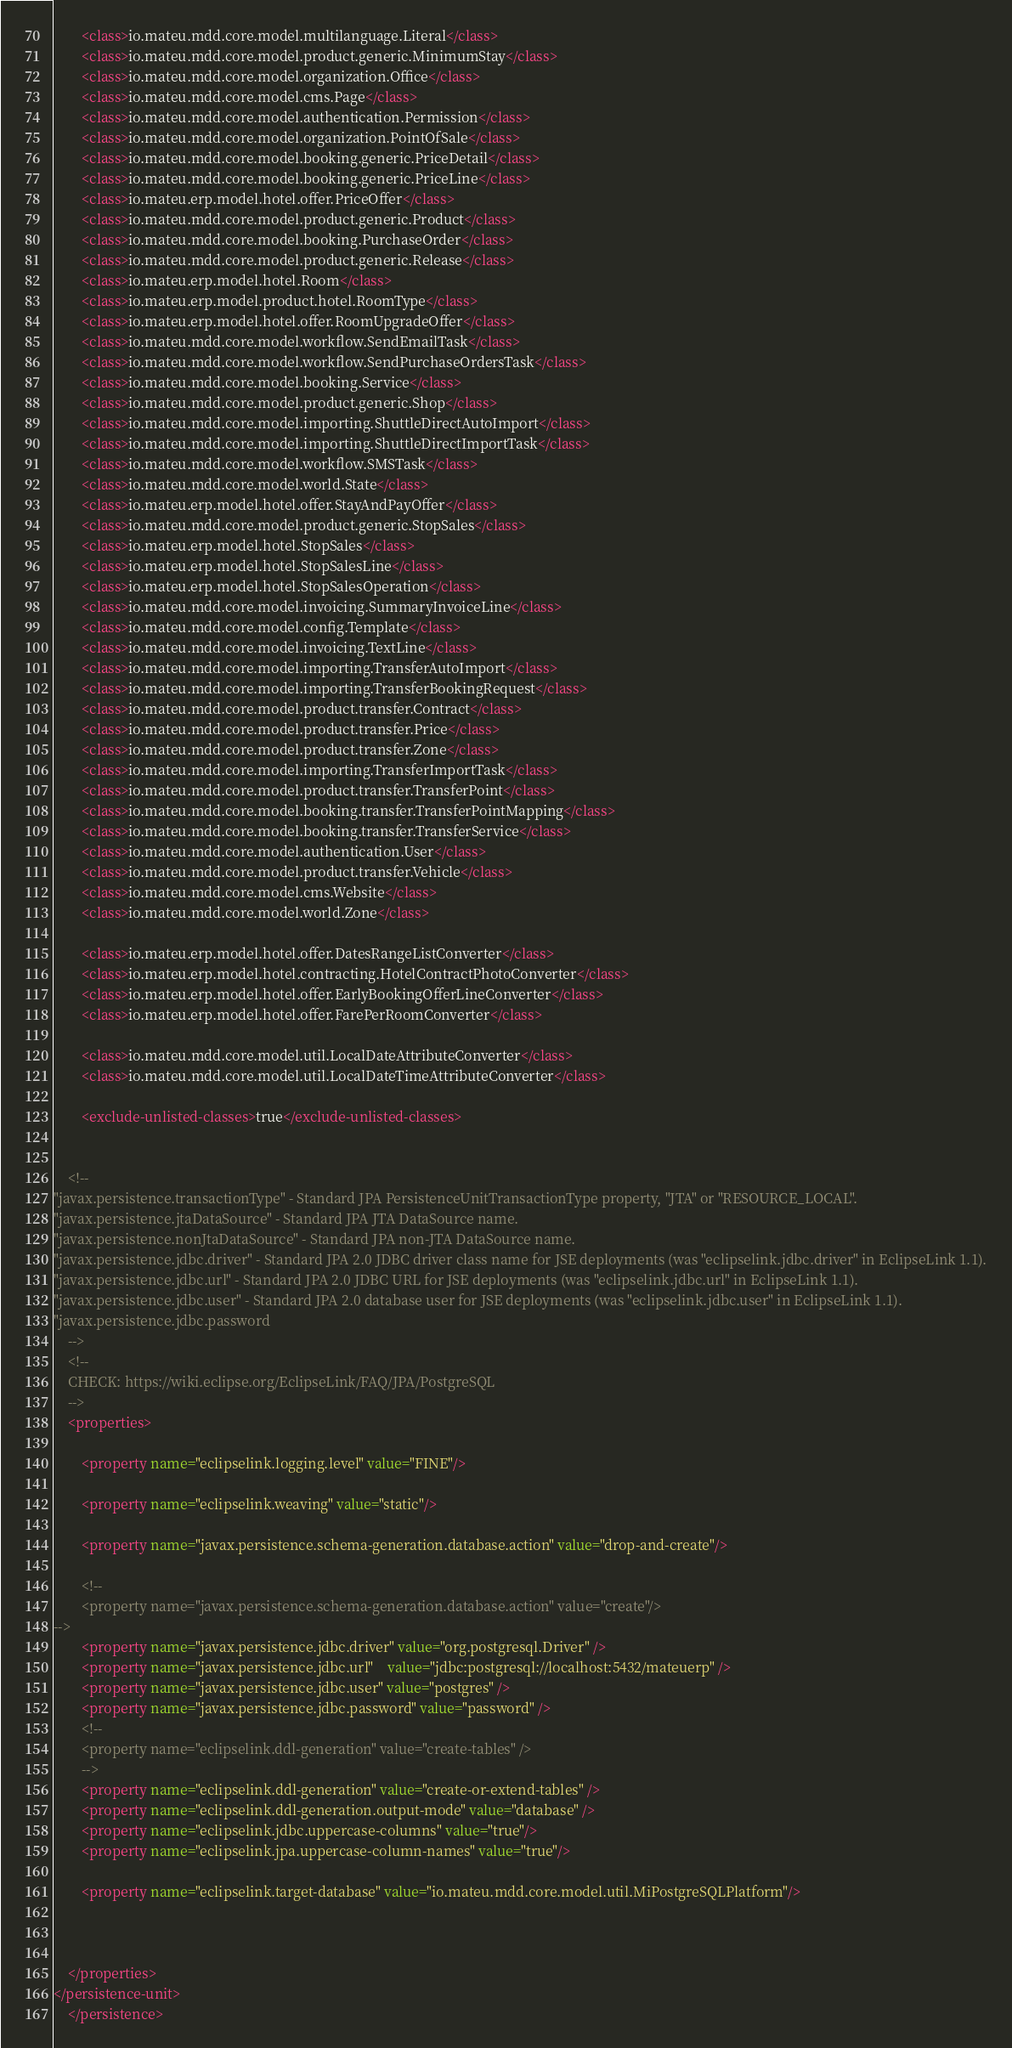<code> <loc_0><loc_0><loc_500><loc_500><_XML_>        <class>io.mateu.mdd.core.model.multilanguage.Literal</class>
        <class>io.mateu.mdd.core.model.product.generic.MinimumStay</class>
        <class>io.mateu.mdd.core.model.organization.Office</class>
        <class>io.mateu.mdd.core.model.cms.Page</class>
        <class>io.mateu.mdd.core.model.authentication.Permission</class>
        <class>io.mateu.mdd.core.model.organization.PointOfSale</class>
        <class>io.mateu.mdd.core.model.booking.generic.PriceDetail</class>
        <class>io.mateu.mdd.core.model.booking.generic.PriceLine</class>
        <class>io.mateu.erp.model.hotel.offer.PriceOffer</class>
        <class>io.mateu.mdd.core.model.product.generic.Product</class>
        <class>io.mateu.mdd.core.model.booking.PurchaseOrder</class>
        <class>io.mateu.mdd.core.model.product.generic.Release</class>
        <class>io.mateu.erp.model.hotel.Room</class>
        <class>io.mateu.erp.model.product.hotel.RoomType</class>
        <class>io.mateu.erp.model.hotel.offer.RoomUpgradeOffer</class>
        <class>io.mateu.mdd.core.model.workflow.SendEmailTask</class>
        <class>io.mateu.mdd.core.model.workflow.SendPurchaseOrdersTask</class>
        <class>io.mateu.mdd.core.model.booking.Service</class>
        <class>io.mateu.mdd.core.model.product.generic.Shop</class>
        <class>io.mateu.mdd.core.model.importing.ShuttleDirectAutoImport</class>
        <class>io.mateu.mdd.core.model.importing.ShuttleDirectImportTask</class>
        <class>io.mateu.mdd.core.model.workflow.SMSTask</class>
        <class>io.mateu.mdd.core.model.world.State</class>
        <class>io.mateu.erp.model.hotel.offer.StayAndPayOffer</class>
        <class>io.mateu.mdd.core.model.product.generic.StopSales</class>
        <class>io.mateu.erp.model.hotel.StopSales</class>
        <class>io.mateu.erp.model.hotel.StopSalesLine</class>
        <class>io.mateu.erp.model.hotel.StopSalesOperation</class>
        <class>io.mateu.mdd.core.model.invoicing.SummaryInvoiceLine</class>
        <class>io.mateu.mdd.core.model.config.Template</class>
        <class>io.mateu.mdd.core.model.invoicing.TextLine</class>
        <class>io.mateu.mdd.core.model.importing.TransferAutoImport</class>
        <class>io.mateu.mdd.core.model.importing.TransferBookingRequest</class>
        <class>io.mateu.mdd.core.model.product.transfer.Contract</class>
        <class>io.mateu.mdd.core.model.product.transfer.Price</class>
        <class>io.mateu.mdd.core.model.product.transfer.Zone</class>
        <class>io.mateu.mdd.core.model.importing.TransferImportTask</class>
        <class>io.mateu.mdd.core.model.product.transfer.TransferPoint</class>
        <class>io.mateu.mdd.core.model.booking.transfer.TransferPointMapping</class>
        <class>io.mateu.mdd.core.model.booking.transfer.TransferService</class>
        <class>io.mateu.mdd.core.model.authentication.User</class>
        <class>io.mateu.mdd.core.model.product.transfer.Vehicle</class>
        <class>io.mateu.mdd.core.model.cms.Website</class>
        <class>io.mateu.mdd.core.model.world.Zone</class>

        <class>io.mateu.erp.model.hotel.offer.DatesRangeListConverter</class>
        <class>io.mateu.erp.model.hotel.contracting.HotelContractPhotoConverter</class>
        <class>io.mateu.erp.model.hotel.offer.EarlyBookingOfferLineConverter</class>
        <class>io.mateu.erp.model.hotel.offer.FarePerRoomConverter</class>

        <class>io.mateu.mdd.core.model.util.LocalDateAttributeConverter</class>
        <class>io.mateu.mdd.core.model.util.LocalDateTimeAttributeConverter</class>

        <exclude-unlisted-classes>true</exclude-unlisted-classes>


    <!--
"javax.persistence.transactionType" - Standard JPA PersistenceUnitTransactionType property, "JTA" or "RESOURCE_LOCAL".
"javax.persistence.jtaDataSource" - Standard JPA JTA DataSource name.
"javax.persistence.nonJtaDataSource" - Standard JPA non-JTA DataSource name.
"javax.persistence.jdbc.driver" - Standard JPA 2.0 JDBC driver class name for JSE deployments (was "eclipselink.jdbc.driver" in EclipseLink 1.1).
"javax.persistence.jdbc.url" - Standard JPA 2.0 JDBC URL for JSE deployments (was "eclipselink.jdbc.url" in EclipseLink 1.1).
"javax.persistence.jdbc.user" - Standard JPA 2.0 database user for JSE deployments (was "eclipselink.jdbc.user" in EclipseLink 1.1).
"javax.persistence.jdbc.password
    -->
    <!--
    CHECK: https://wiki.eclipse.org/EclipseLink/FAQ/JPA/PostgreSQL
    -->
    <properties>

        <property name="eclipselink.logging.level" value="FINE"/>

        <property name="eclipselink.weaving" value="static"/>

        <property name="javax.persistence.schema-generation.database.action" value="drop-and-create"/>

        <!--
        <property name="javax.persistence.schema-generation.database.action" value="create"/>
-->
        <property name="javax.persistence.jdbc.driver" value="org.postgresql.Driver" />
        <property name="javax.persistence.jdbc.url"    value="jdbc:postgresql://localhost:5432/mateuerp" />
        <property name="javax.persistence.jdbc.user" value="postgres" />
        <property name="javax.persistence.jdbc.password" value="password" />
        <!--
        <property name="eclipselink.ddl-generation" value="create-tables" />
        -->
        <property name="eclipselink.ddl-generation" value="create-or-extend-tables" />
        <property name="eclipselink.ddl-generation.output-mode" value="database" />
        <property name="eclipselink.jdbc.uppercase-columns" value="true"/>
        <property name="eclipselink.jpa.uppercase-column-names" value="true"/>

        <property name="eclipselink.target-database" value="io.mateu.mdd.core.model.util.MiPostgreSQLPlatform"/>



    </properties>
</persistence-unit>
    </persistence></code> 